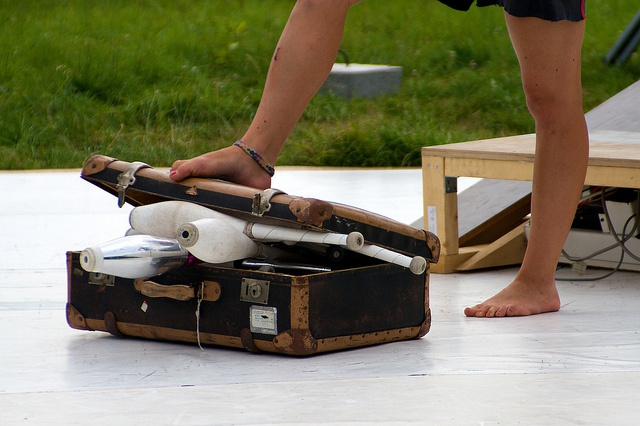Describe the objects in this image and their specific colors. I can see suitcase in darkgreen, black, maroon, and gray tones and people in darkgreen, brown, and maroon tones in this image. 